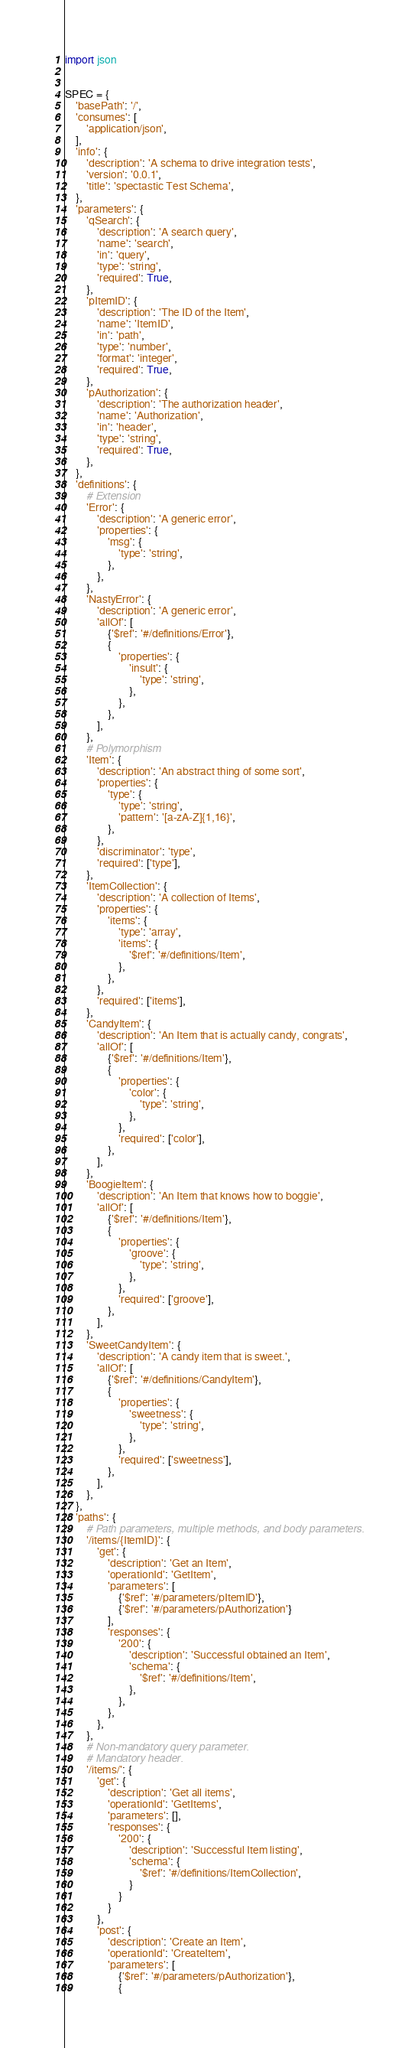<code> <loc_0><loc_0><loc_500><loc_500><_Python_>import json


SPEC = {
    'basePath': '/',
    'consumes': [
        'application/json',
    ],
    'info': {
        'description': 'A schema to drive integration tests',
        'version': '0.0.1',
        'title': 'spectastic Test Schema',
    },
    'parameters': {
        'qSearch': {
            'description': 'A search query',
            'name': 'search',
            'in': 'query',
            'type': 'string',
            'required': True,
        },
        'pItemID': {
            'description': 'The ID of the Item',
            'name': 'ItemID',
            'in': 'path',
            'type': 'number',
            'format': 'integer',
            'required': True,
        },
        'pAuthorization': {
            'description': 'The authorization header',
            'name': 'Authorization',
            'in': 'header',
            'type': 'string',
            'required': True,
        },
    },
    'definitions': {
        # Extension
        'Error': {
            'description': 'A generic error',
            'properties': {
                'msg': {
                    'type': 'string',
                },
            },
        },
        'NastyError': {
            'description': 'A generic error',
            'allOf': [
                {'$ref': '#/definitions/Error'},
                {
                    'properties': {
                        'insult': {
                            'type': 'string',
                        },
                    },
                },
            ],
        },
        # Polymorphism
        'Item': {
            'description': 'An abstract thing of some sort',
            'properties': {
                'type': {
                    'type': 'string',
                    'pattern': '[a-zA-Z]{1,16}',
                },
            },
            'discriminator': 'type',
            'required': ['type'],
        },
        'ItemCollection': {
            'description': 'A collection of Items',
            'properties': {
                'items': {
                    'type': 'array',
                    'items': {
                        '$ref': '#/definitions/Item',
                    },
                },
            },
            'required': ['items'],
        },
        'CandyItem': {
            'description': 'An Item that is actually candy, congrats',
            'allOf': [
                {'$ref': '#/definitions/Item'},
                {
                    'properties': {
                        'color': {
                            'type': 'string',
                        },
                    },
                    'required': ['color'],
                },
            ],
        },
        'BoogieItem': {
            'description': 'An Item that knows how to boggie',
            'allOf': [
                {'$ref': '#/definitions/Item'},
                {
                    'properties': {
                        'groove': {
                            'type': 'string',
                        },
                    },
                    'required': ['groove'],
                },
            ],
        },
        'SweetCandyItem': {
            'description': 'A candy item that is sweet.',
            'allOf': [
                {'$ref': '#/definitions/CandyItem'},
                {
                    'properties': {
                        'sweetness': {
                            'type': 'string',
                        },
                    },
                    'required': ['sweetness'],
                },
            ],
        },
    },
    'paths': {
        # Path parameters, multiple methods, and body parameters.
        '/items/{ItemID}': {
            'get': {
                'description': 'Get an Item',
                'operationId': 'GetItem',
                'parameters': [
                    {'$ref': '#/parameters/pItemID'},
                    {'$ref': '#/parameters/pAuthorization'}
                ],
                'responses': {
                    '200': {
                        'description': 'Successful obtained an Item',
                        'schema': {
                            '$ref': '#/definitions/Item',
                        },
                    },
                },
            },
        },
        # Non-mandatory query parameter.
        # Mandatory header.
        '/items/': {
            'get': {
                'description': 'Get all items',
                'operationId': 'GetItems',
                'parameters': [],
                'responses': {
                    '200': {
                        'description': 'Successful Item listing',
                        'schema': {
                            '$ref': '#/definitions/ItemCollection',
                        }
                    }
                }
            },
            'post': {
                'description': 'Create an Item',
                'operationId': 'CreateItem',
                'parameters': [
                    {'$ref': '#/parameters/pAuthorization'},
                    {</code> 